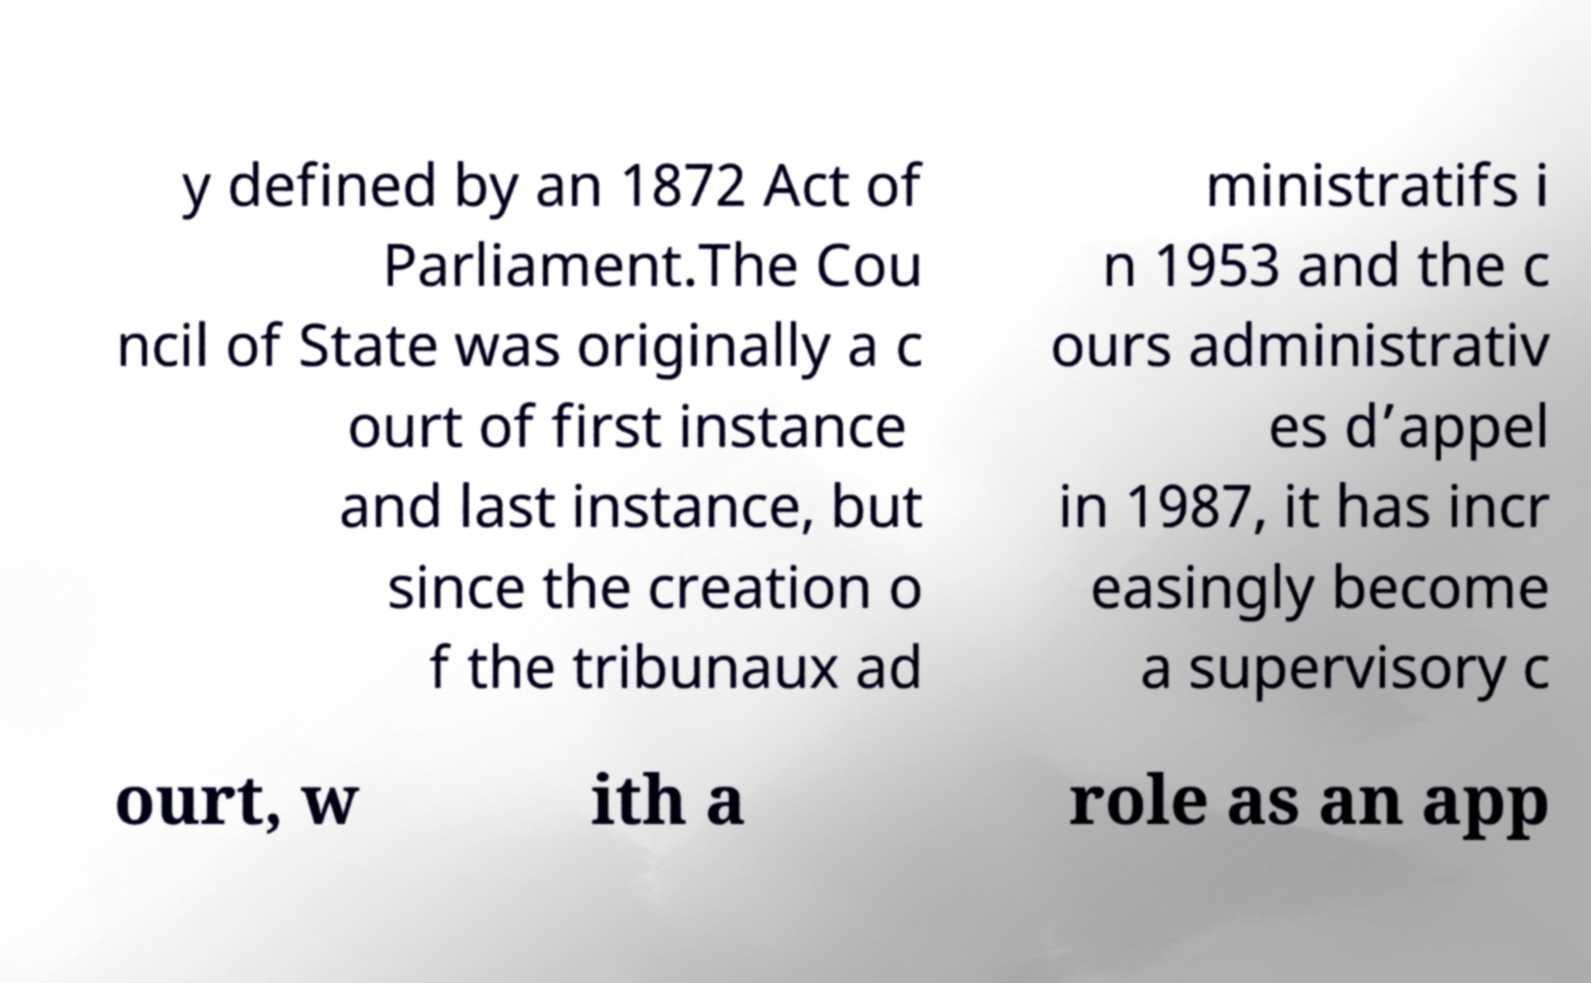For documentation purposes, I need the text within this image transcribed. Could you provide that? y defined by an 1872 Act of Parliament.The Cou ncil of State was originally a c ourt of first instance and last instance, but since the creation o f the tribunaux ad ministratifs i n 1953 and the c ours administrativ es d’appel in 1987, it has incr easingly become a supervisory c ourt, w ith a role as an app 